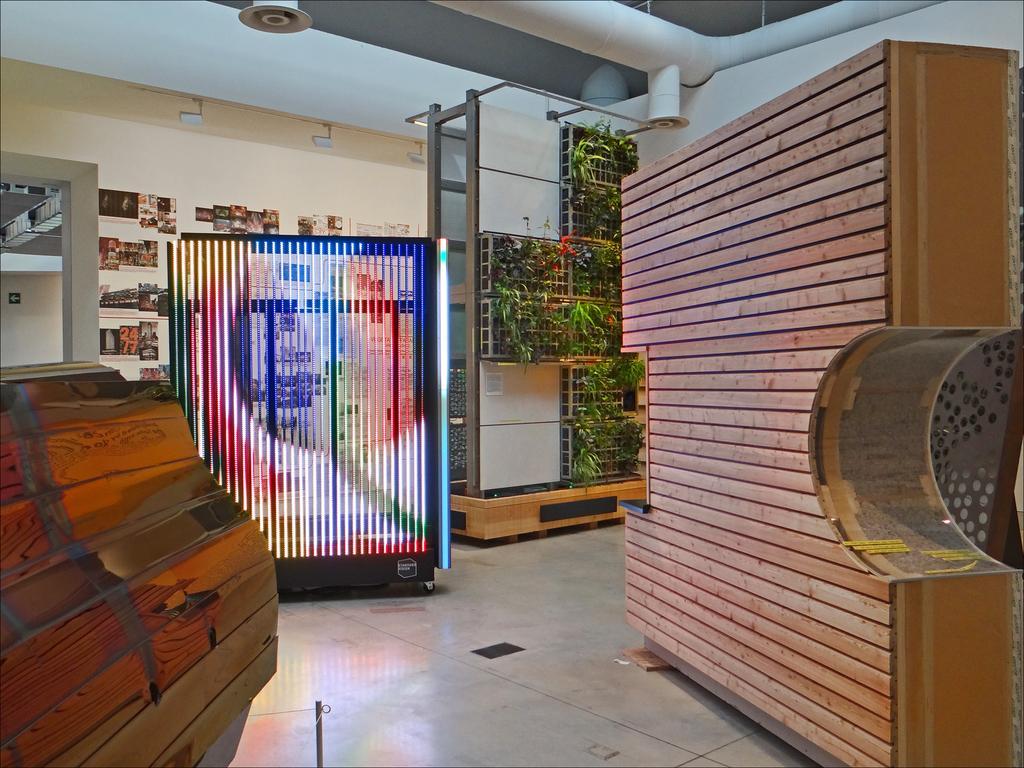Can you describe this image briefly? In this image I can see the wooden table, the wooden wall, the floor and object to which I can see red, white and blue colored lights. In the background I can see the cream colored wall, few photos attached to the wall, the ceiling, a white colored pipe and few lights to the ceiling. 